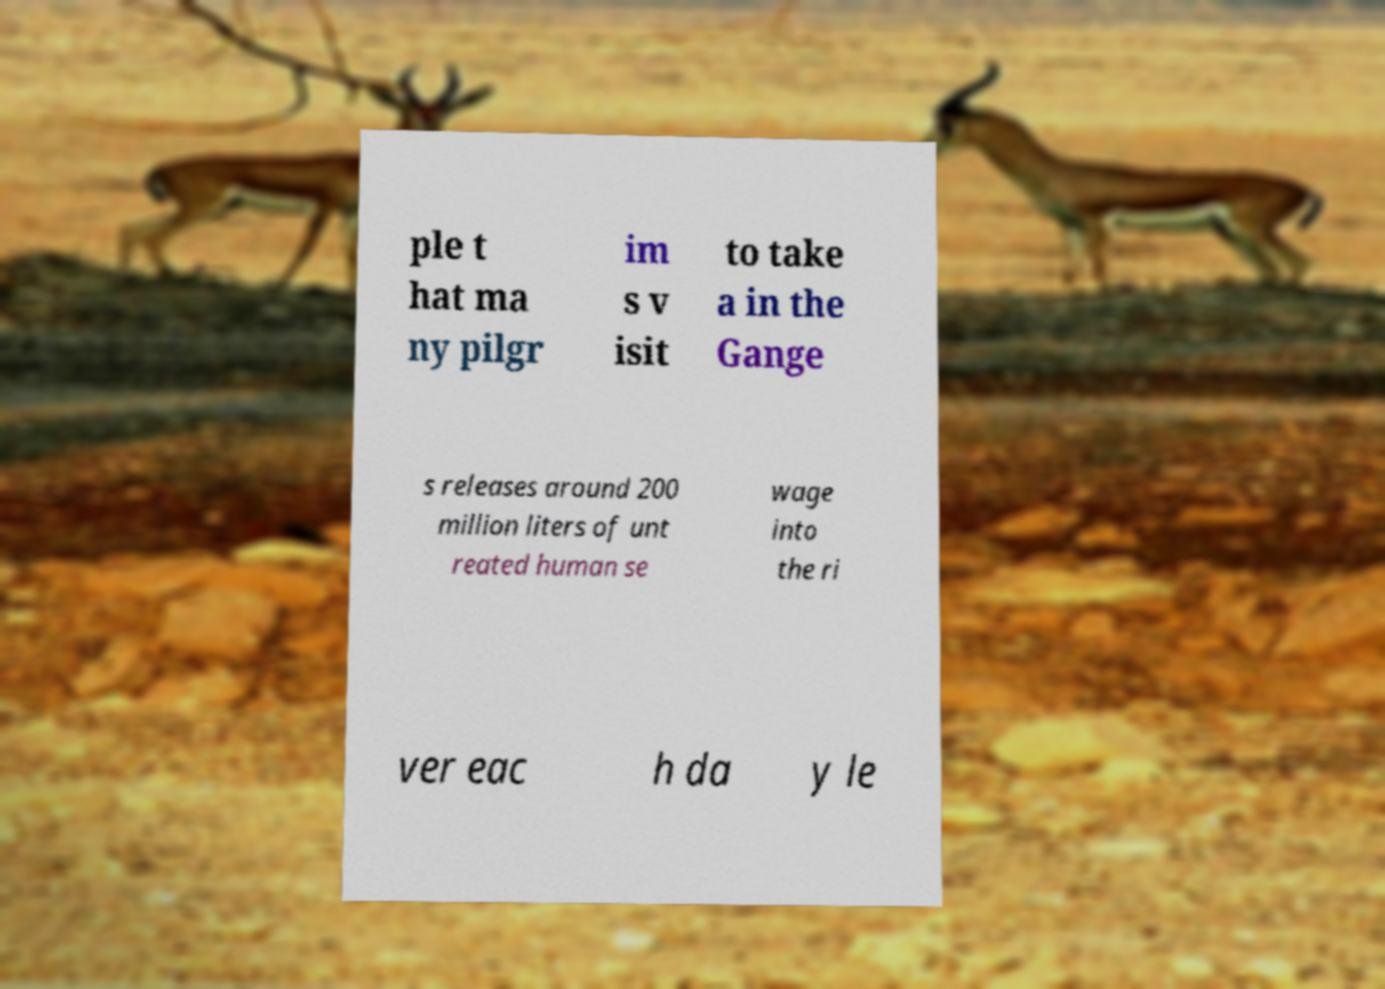Can you read and provide the text displayed in the image?This photo seems to have some interesting text. Can you extract and type it out for me? ple t hat ma ny pilgr im s v isit to take a in the Gange s releases around 200 million liters of unt reated human se wage into the ri ver eac h da y le 